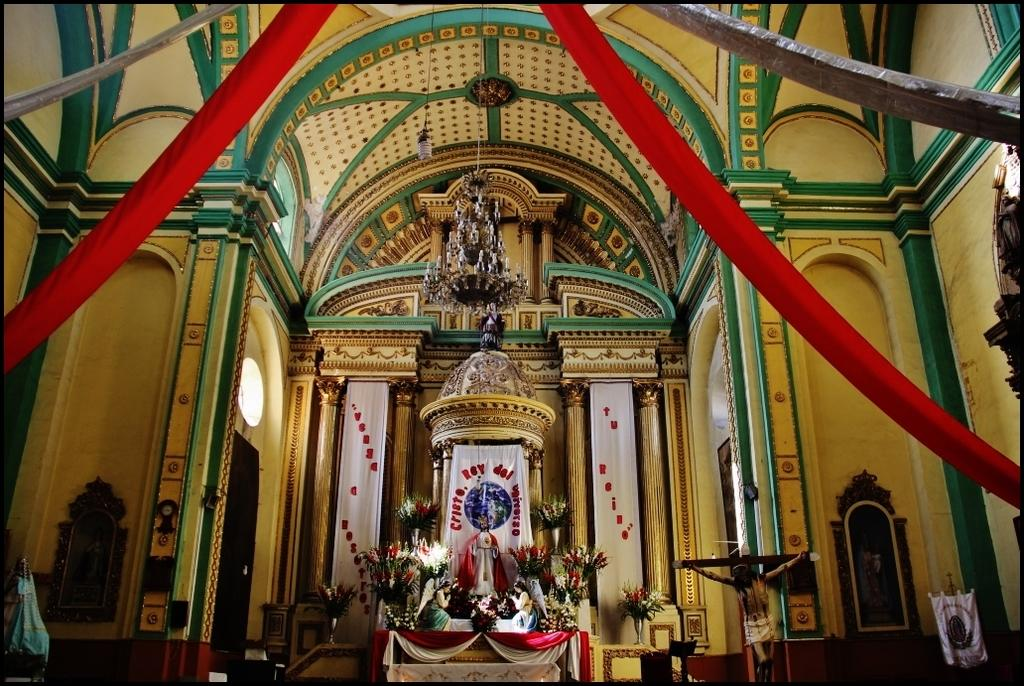What type of location might the image have been taken in? The image might have been taken in a church. What can be seen in the image besides the location? There is a statue, flowers, curtains, windows, statues (plural), light, pillars, a ventilator, and a wall in the image. Can you describe the statue in the image? There is a statue in the image, but the specific details of the statue are not mentioned in the provided facts. What type of vegetation is present in the image? There are flowers in the image. What architectural features can be seen in the image? There are pillars and a wall in the image. What type of lighting is present in the image? There is light in the image. What type of apparel is the statue wearing in the image? There is no information about the statue's apparel in the provided facts, and therefore it cannot be determined from the image. 